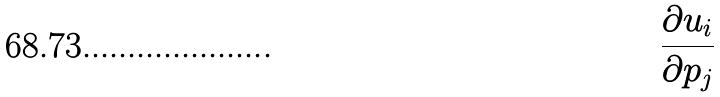<formula> <loc_0><loc_0><loc_500><loc_500>\frac { \partial u _ { i } } { \partial p _ { j } }</formula> 